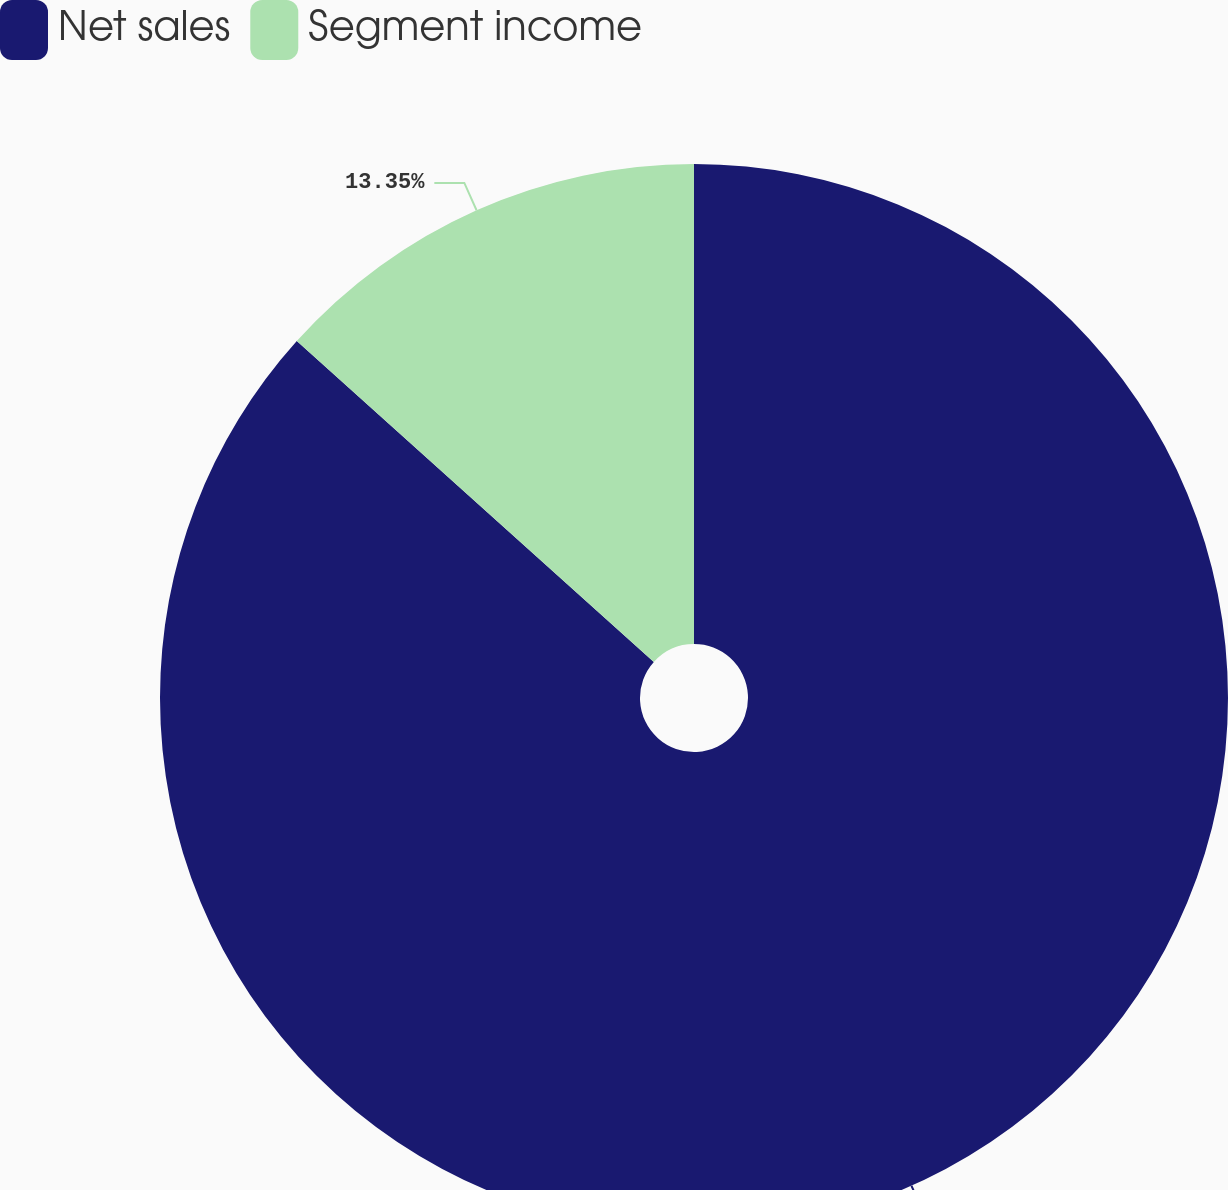<chart> <loc_0><loc_0><loc_500><loc_500><pie_chart><fcel>Net sales<fcel>Segment income<nl><fcel>86.65%<fcel>13.35%<nl></chart> 